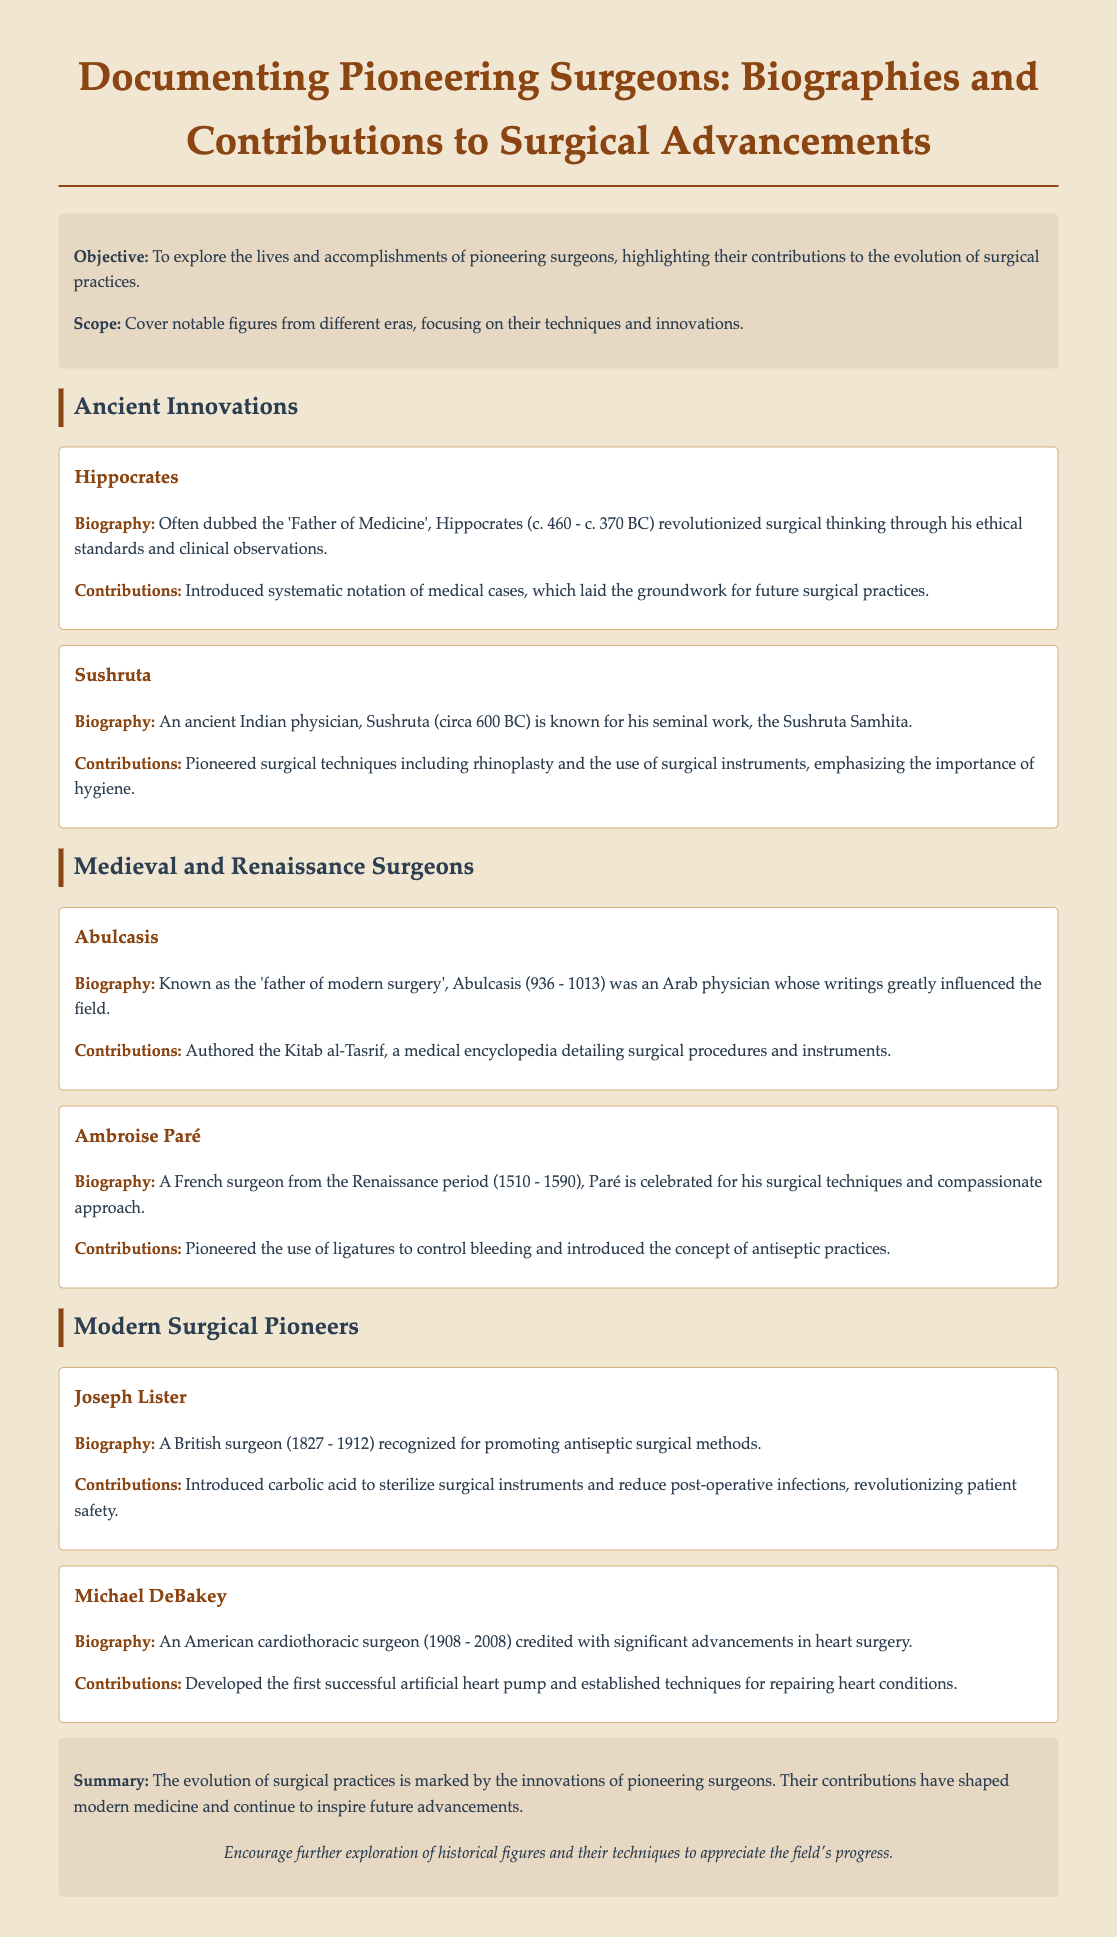What is the objective of the document? The objective is stated as exploring the lives and accomplishments of pioneering surgeons, highlighting their contributions to the evolution of surgical practices.
Answer: To explore the lives and accomplishments of pioneering surgeons Who is known as the 'Father of Medicine'? The document mentions Hippocrates as often being referred to as the 'Father of Medicine'.
Answer: Hippocrates What surgical technique did Sushruta pioneer? The document notes that Sushruta pioneered surgical techniques including rhinoplasty.
Answer: Rhinoplasty Which surgeon introduced carbolic acid for sterilization? The document states that Joseph Lister introduced carbolic acid to sterilize surgical instruments.
Answer: Joseph Lister What era does Ambroise Paré belong to? The document mentions Ambroise Paré was a French surgeon from the Renaissance period.
Answer: Renaissance period What is the title of Abulcasis's significant work? The document states that Abulcasis authored the Kitab al-Tasrif.
Answer: Kitab al-Tasrif Which surgeon is credited with the first successful artificial heart pump? The document attributes this achievement to Michael DeBakey.
Answer: Michael DeBakey What is the summary of the document? The summary states that the evolution of surgical practices is marked by innovations of pioneering surgeons.
Answer: The evolution of surgical practices is marked by innovations of pioneering surgeons 